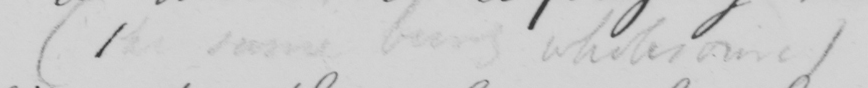Can you tell me what this handwritten text says? ( the same being wholesome ) 